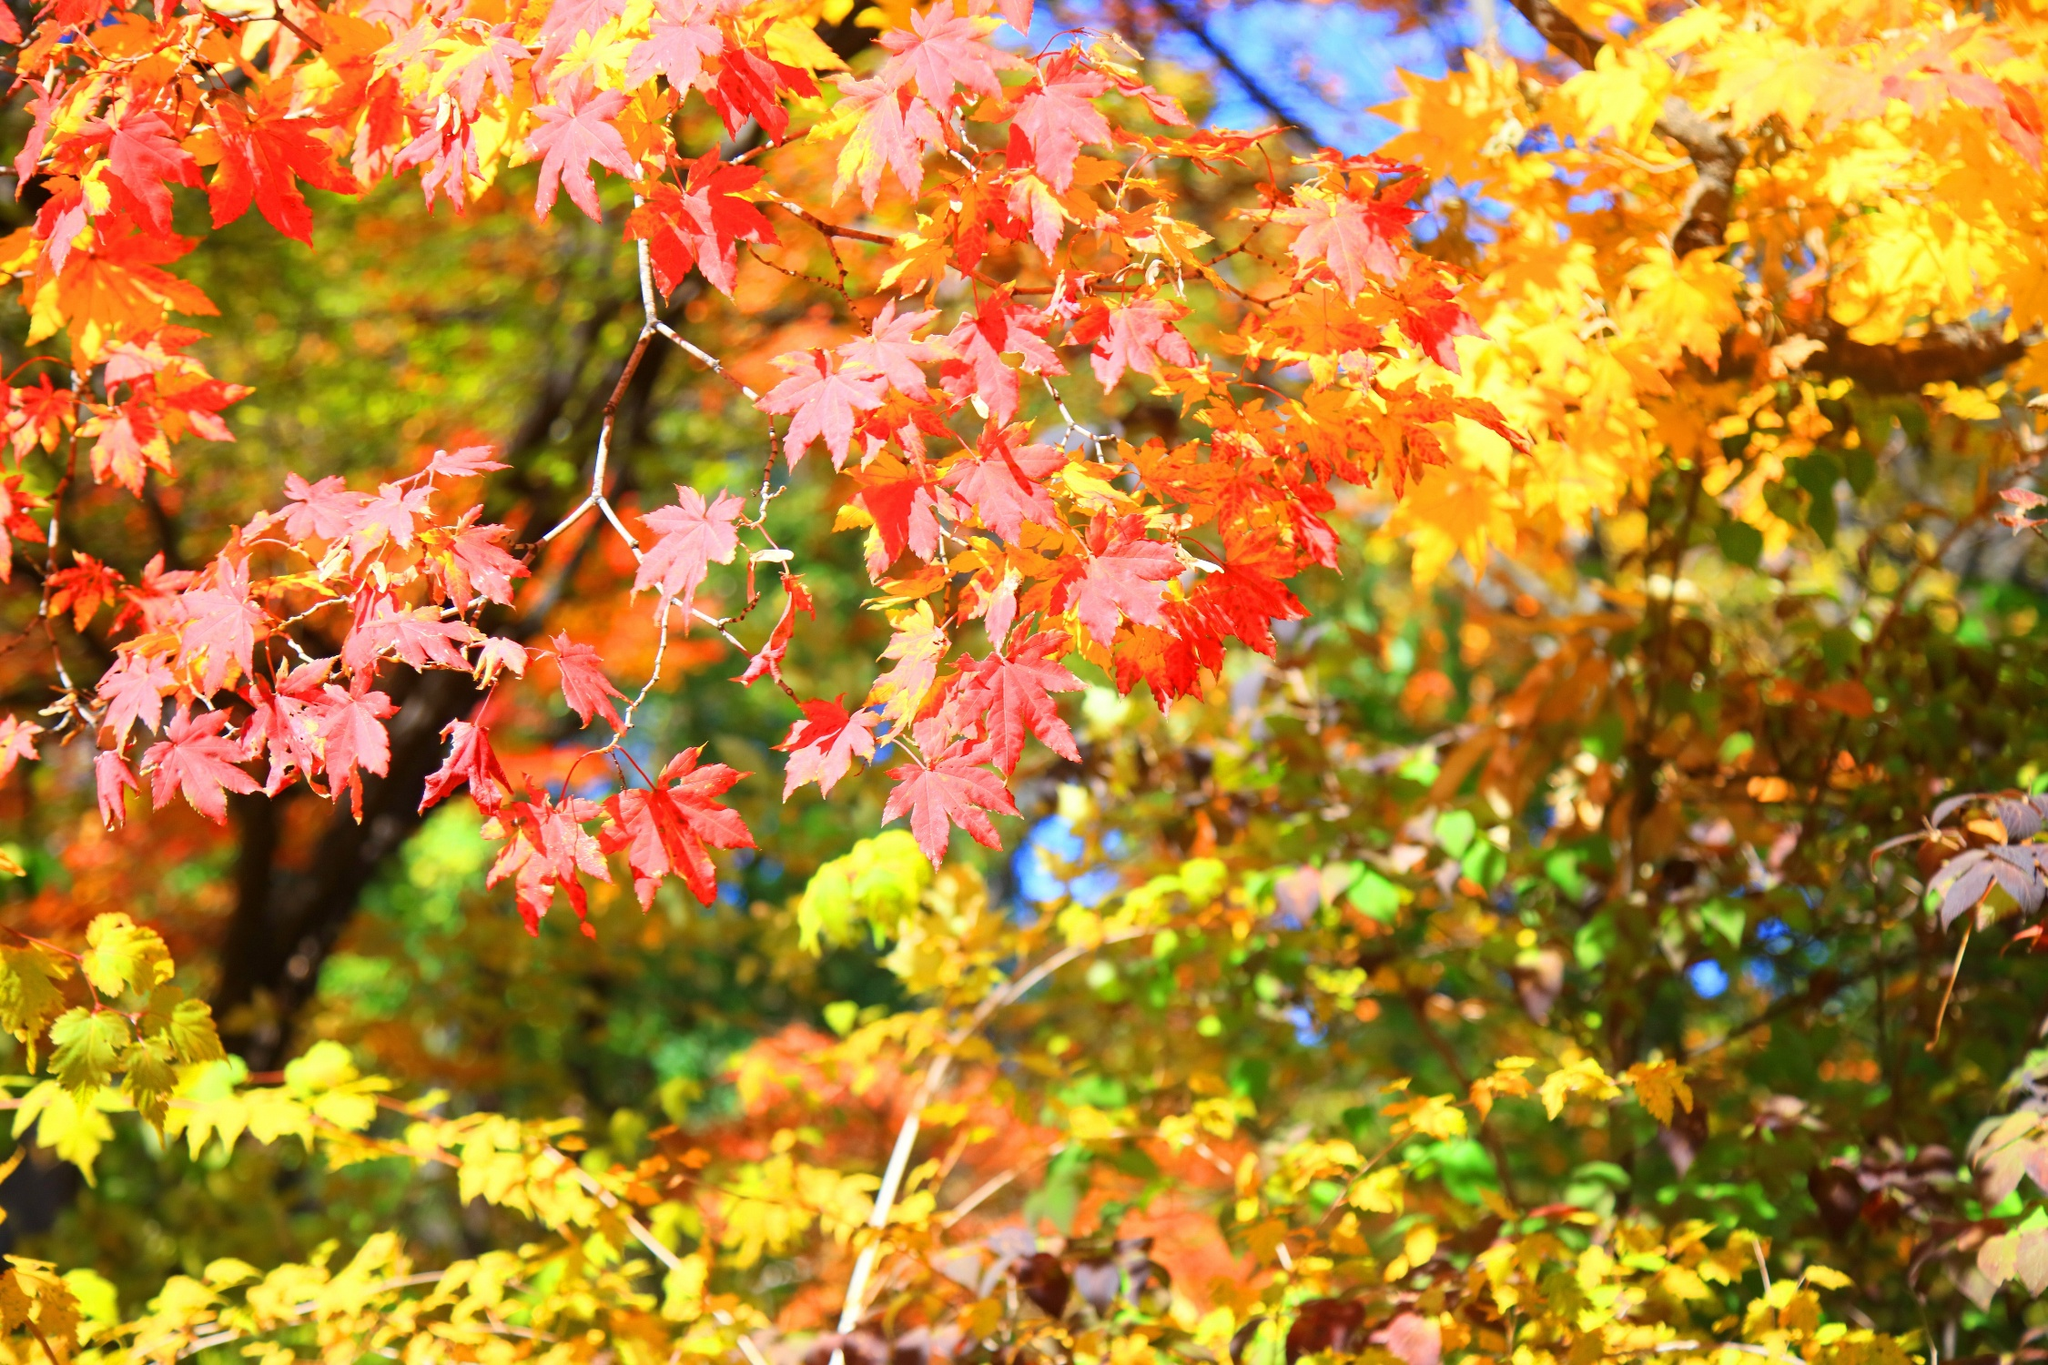If you were standing under this tree, what might you experience? Standing under this tree, you would be enveloped in a canopy of vivid reds, oranges, and yellows. The cool, crisp air would carry the earthy scent of fallen leaves, mixed with a slight hint of pine. Gentle rustling sounds from the leaves above would create a soothing, rhythmic backdrop. Occasionally, a playful breeze would send a cascade of colorful leaves fluttering down, adding to the sense of tranquility and wonder. 